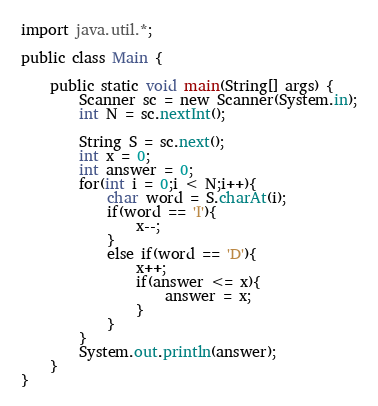Convert code to text. <code><loc_0><loc_0><loc_500><loc_500><_Java_>import java.util.*;

public class Main {

	public static void main(String[] args) {
		Scanner sc = new Scanner(System.in);
		int N = sc.nextInt();
		
		String S = sc.next();
		int x = 0;
		int answer = 0;
		for(int i = 0;i < N;i++){
			char word = S.charAt(i);
			if(word == 'I'){
				x--;
			}
			else if(word == 'D'){
				x++;
				if(answer <= x){
					answer = x;
				}
			}
		}
		System.out.println(answer);	
	}
}</code> 